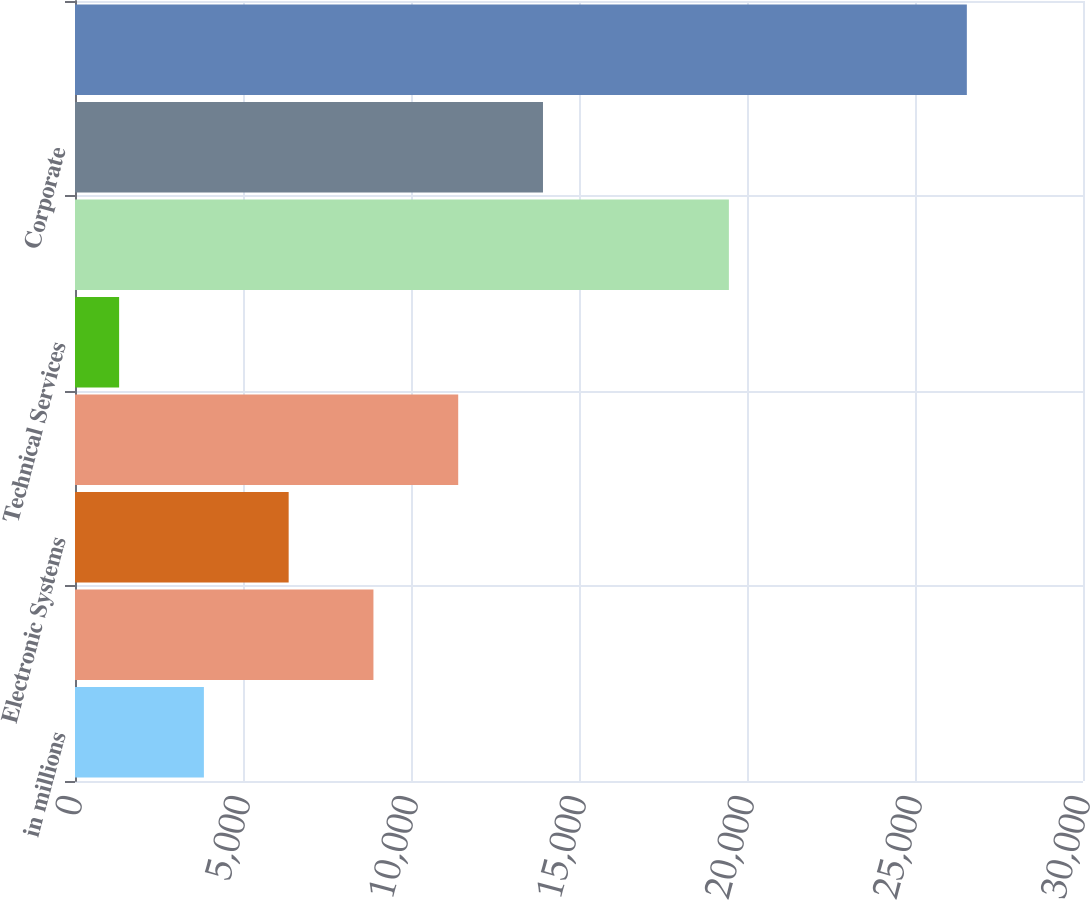Convert chart. <chart><loc_0><loc_0><loc_500><loc_500><bar_chart><fcel>in millions<fcel>Aerospace Systems<fcel>Electronic Systems<fcel>Information Systems<fcel>Technical Services<fcel>Segment assets<fcel>Corporate<fcel>Total assets<nl><fcel>3836<fcel>8882<fcel>6359<fcel>11405<fcel>1313<fcel>19461<fcel>13928<fcel>26543<nl></chart> 